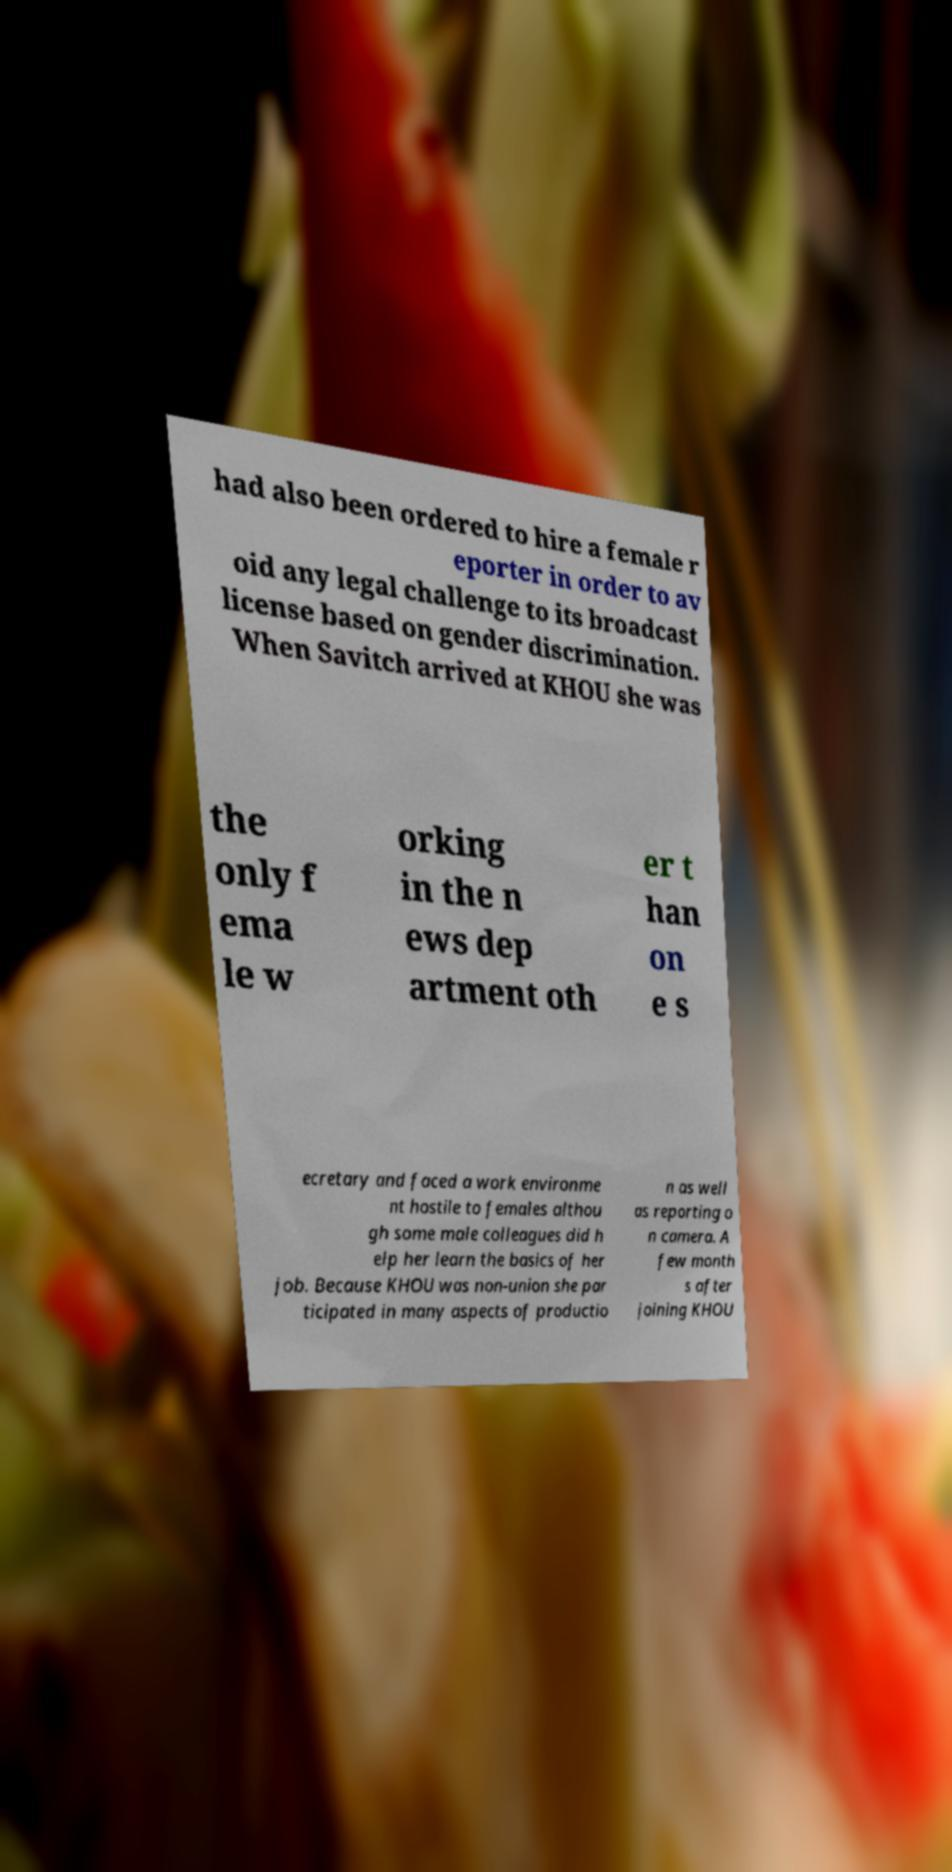Could you extract and type out the text from this image? had also been ordered to hire a female r eporter in order to av oid any legal challenge to its broadcast license based on gender discrimination. When Savitch arrived at KHOU she was the only f ema le w orking in the n ews dep artment oth er t han on e s ecretary and faced a work environme nt hostile to females althou gh some male colleagues did h elp her learn the basics of her job. Because KHOU was non-union she par ticipated in many aspects of productio n as well as reporting o n camera. A few month s after joining KHOU 